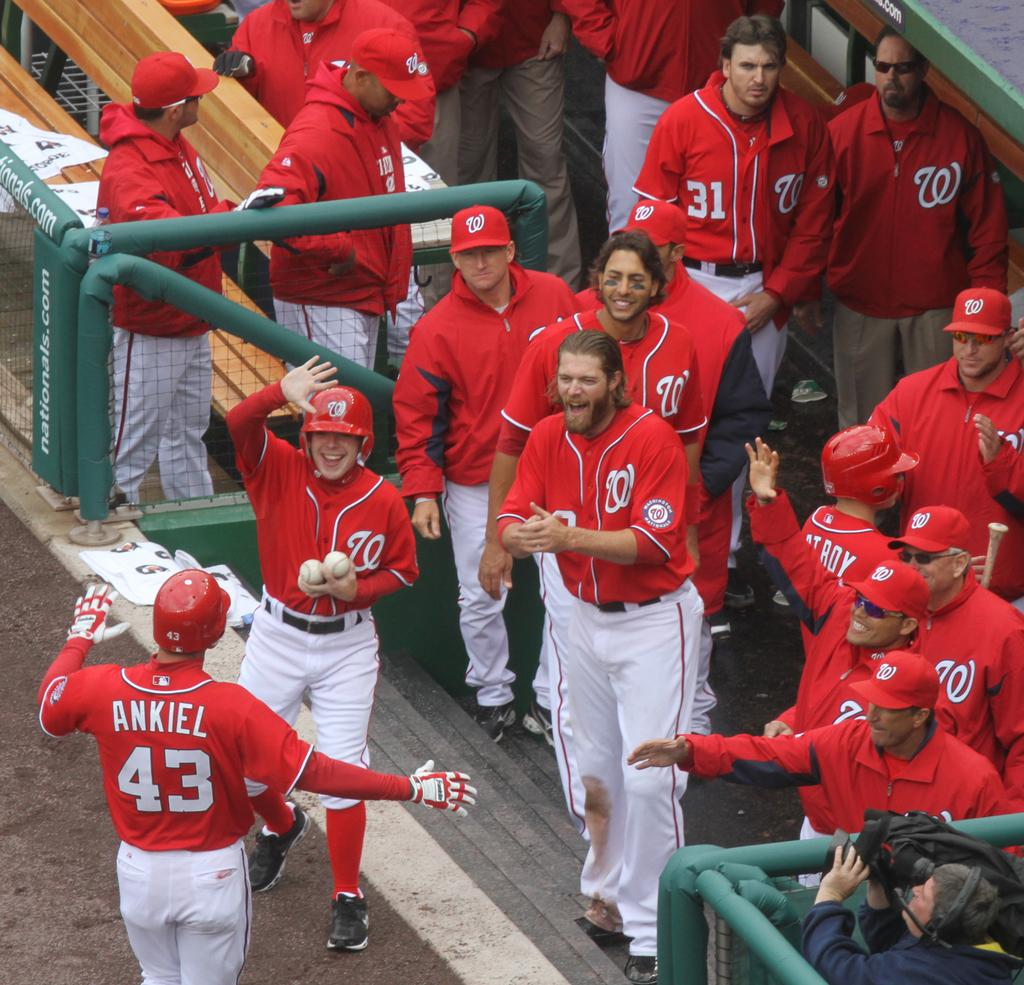Provide a one-sentence caption for the provided image. A baseball team giving a high five to a player named Ankiel as he walks towards the dug out. 